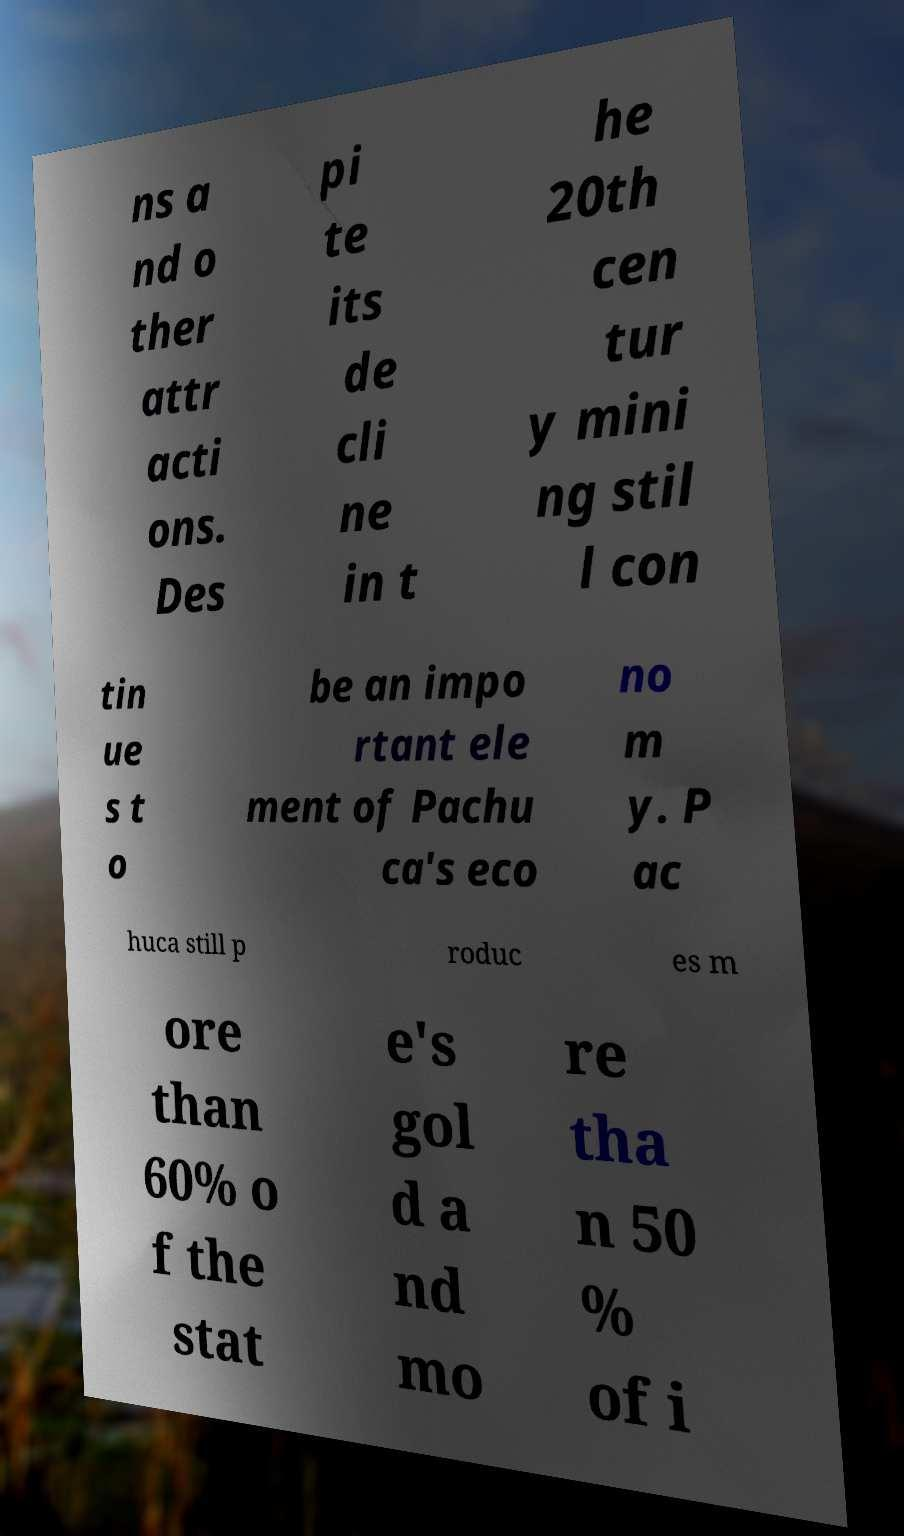I need the written content from this picture converted into text. Can you do that? ns a nd o ther attr acti ons. Des pi te its de cli ne in t he 20th cen tur y mini ng stil l con tin ue s t o be an impo rtant ele ment of Pachu ca's eco no m y. P ac huca still p roduc es m ore than 60% o f the stat e's gol d a nd mo re tha n 50 % of i 